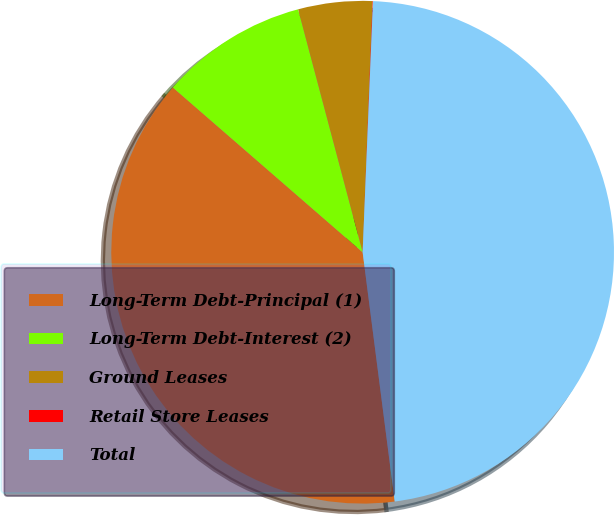<chart> <loc_0><loc_0><loc_500><loc_500><pie_chart><fcel>Long-Term Debt-Principal (1)<fcel>Long-Term Debt-Interest (2)<fcel>Ground Leases<fcel>Retail Store Leases<fcel>Total<nl><fcel>38.42%<fcel>9.49%<fcel>4.76%<fcel>0.03%<fcel>47.31%<nl></chart> 